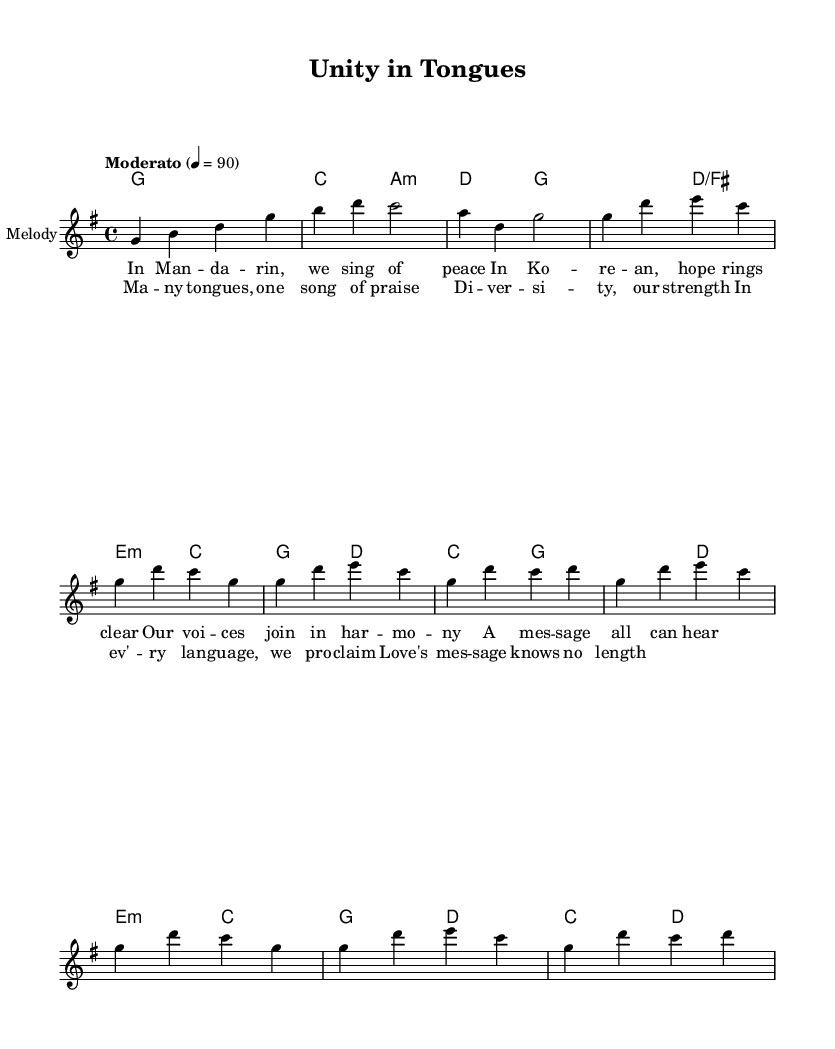What is the key signature of this music? The key signature is indicated by the placement of sharps or flats at the beginning of the staff. In this case, there are no sharps or flats, which identifies it as G major.
Answer: G major What is the time signature of this music? The time signature appears at the beginning of the staff, where the numbers indicate beats per measure. Here, the 4/4 indicates that there are four beats in each measure and a quarter note receives one beat.
Answer: 4/4 What is the tempo marking for this piece? The tempo marking is found at the top of the score, indicating the speed at which the piece should be played. In this case, it is labeled as "Moderato" with a metronome marking of 90 beats per minute.
Answer: Moderato, 90 How many verses are present in this piece? The lyrics segment indicates there is one verse (verse 1) followed by a chorus, which is usually a common structure in religious music.
Answer: One What is the primary theme conveyed in the lyrics? Analyzing the lyrics shows that the piece celebrates linguistic diversity and the unity of voices singing praises in different languages, emphasizing peace and hope.
Answer: Unity in diversity What type of harmony is utilized throughout the piece? The score outlines the harmony as simple triadic chords which support the melody, indicating a common practice in gospel music to accompany the lyrics harmoniously.
Answer: Triadic chords What is the message inspired by this musical piece? A careful reading of the chorus lyrics suggests the message revolves around love and diversity in worship, asserting that love's message transcends linguistic boundaries.
Answer: Love's message knows no length 